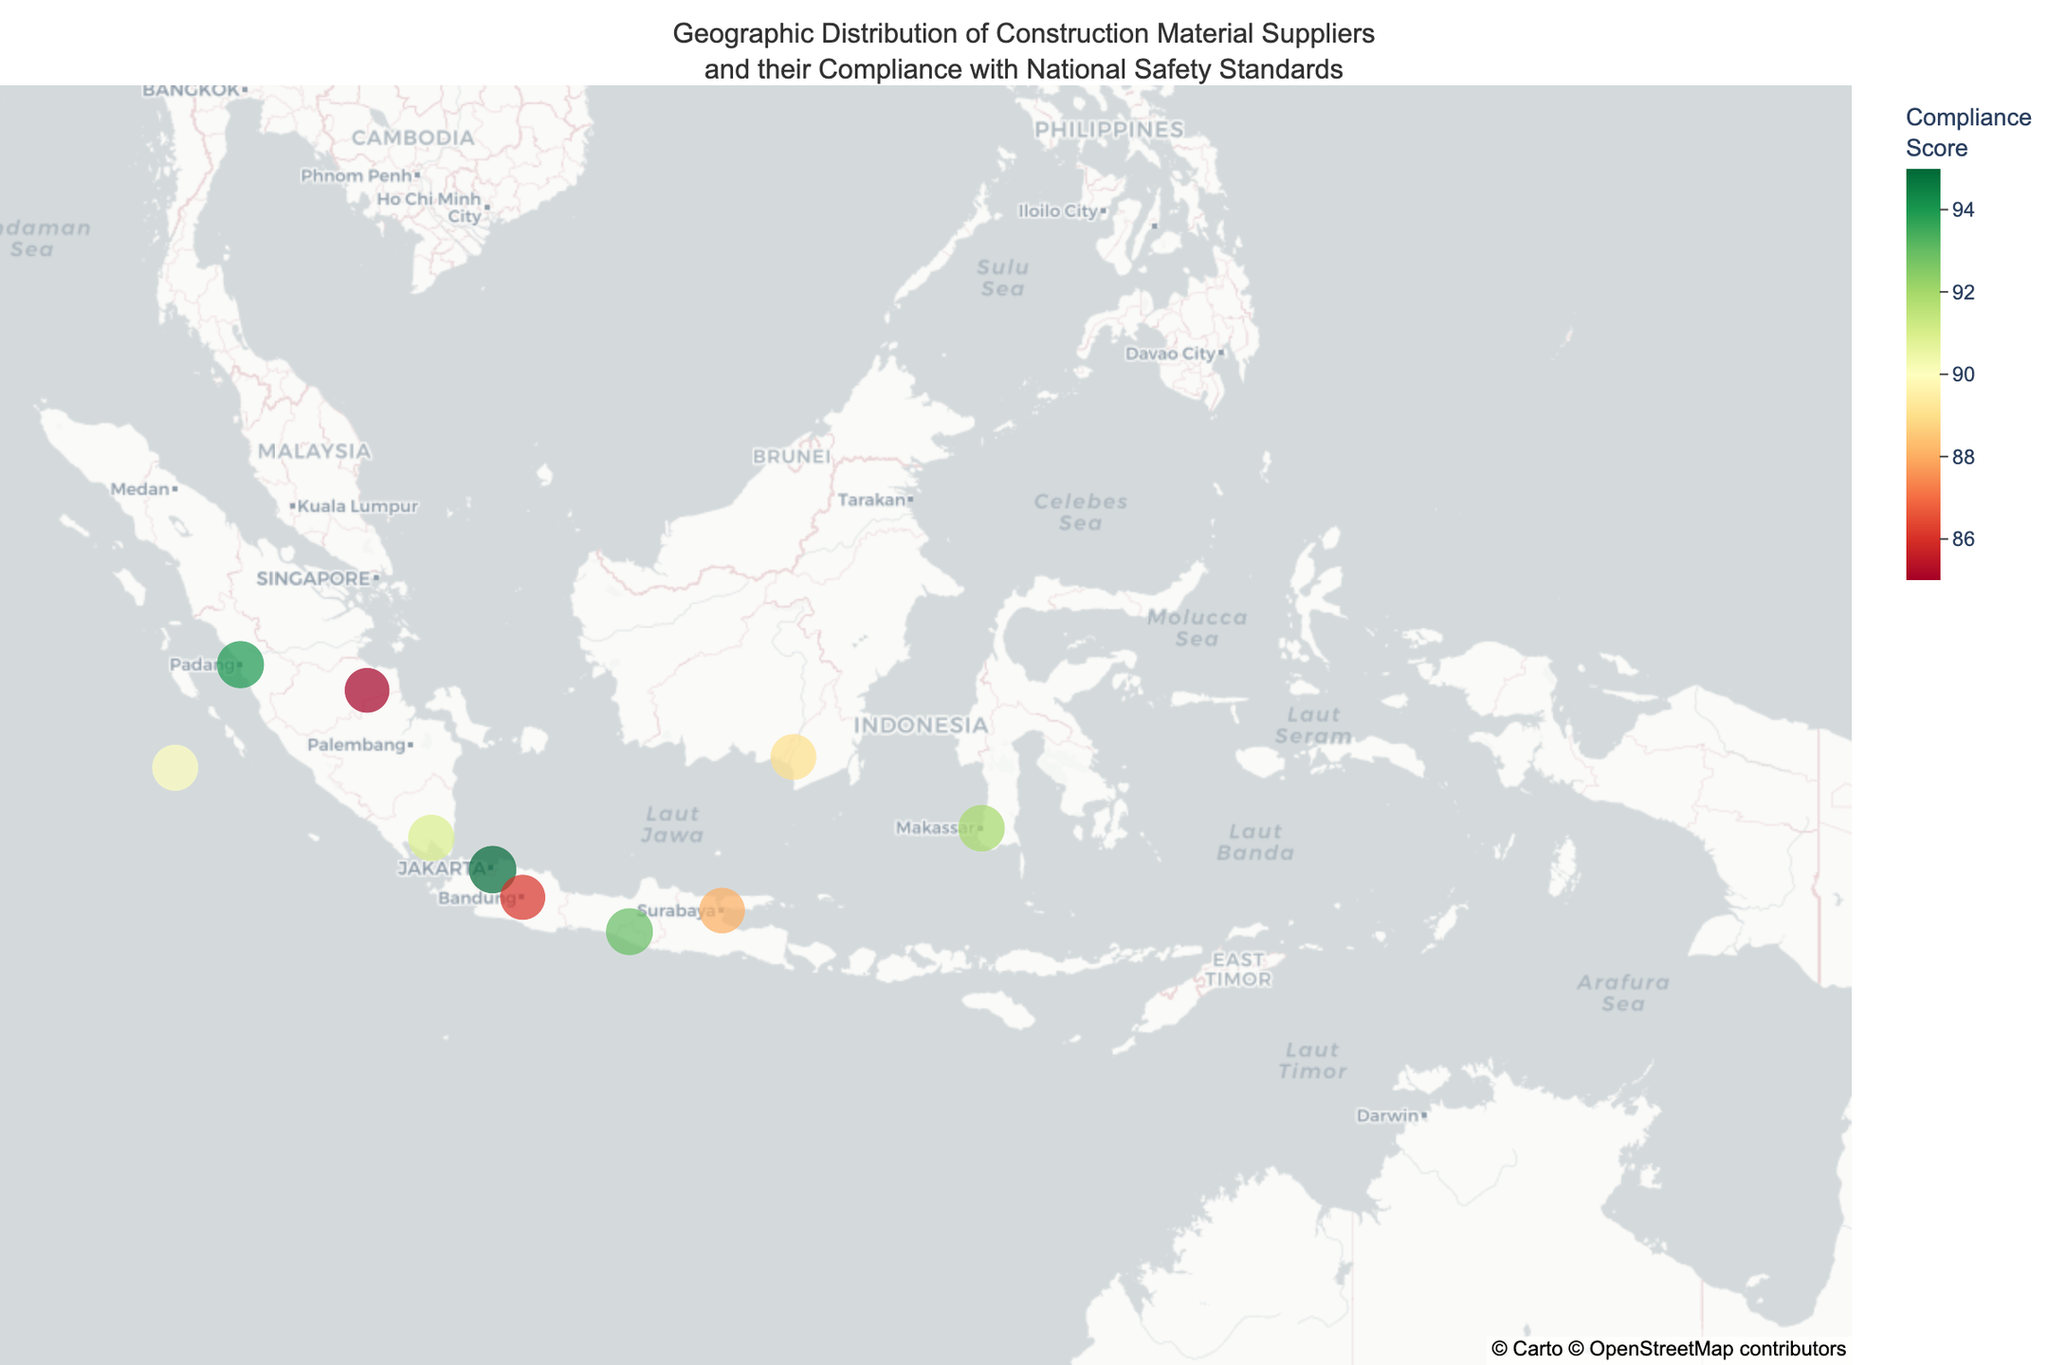What is the average compliance score of all suppliers on the map? To get the average compliance score, add up all the compliance scores and then divide by the number of suppliers. The scores are 95, 88, 92, 90, 94, 86, 93, 89, 91, and 85. The total sum is 903. There are 10 suppliers, so the average compliance score is 903 / 10.
Answer: 90.3 Which city has the highest compliance score? To find the city with the highest compliance score, look at the compliance scores for each city. The highest score is 95, corresponding to Jakarta.
Answer: Jakarta Are there more suppliers dealing with cement or precast concrete? Count the number of suppliers for each type of material. There are 5 suppliers dealing with cement and 3 with precast concrete.
Answer: Cement How many suppliers have a compliance score below 90? Check each supplier's compliance score and count those below 90. The scores below 90 are 88, 86, and 85, so there are 3 such suppliers.
Answer: 3 Which province has the most suppliers? Look at the provinces for each supplier and count the suppliers in each province. West Sumatra, West Java, and DKI Jakarta each have one supplier. There is no province with more than one supplier on the map.
Answer: None (Tie: West Sumatra, West Java, DKI Jakarta) Which supplier has the lowest compliance score and what material do they provide? Find the supplier with the lowest compliance score which is 85, and note the material they provide which is Timber by PT Batanghari Barisan in Jambi.
Answer: PT Batanghari Barisan, Timber Is there a geographic tendency for higher compliance scores (e.g., concentration in a particular region)? Review the map for geographic clustering of high compliance scores. High compliance scores (above 90) are spread out across different regions such as Jakarta, Makassar, Padang, and Yogyakarta, indicating no strong geographic concentration.
Answer: No strong geographic tendency Which cities have compliance scores above 90 and what materials do they primarily supply? Check for cities with compliance scores above 90. These cities are Jakarta (Cement), Makassar (Cement), Medan (Precast Concrete), Padang (Cement), Yogyakarta (Cement), and Bandar Lampung (Steel).
Answer: Jakarta (Cement), Makassar (Cement), Medan (Precast Concrete), Padang (Cement), Yogyakarta (Cement), Bandar Lampung (Steel) How does the compliance score distribution differ between suppliers of cement and precast concrete? Compare the compliance scores of cement suppliers (95, 92, 94, 93, 89) with those of precast concrete suppliers (88, 90, 86). Cement suppliers tend to have higher compliance scores, averaging 92.6 compared to precast concrete at 88.
Answer: Cement suppliers have higher scores 